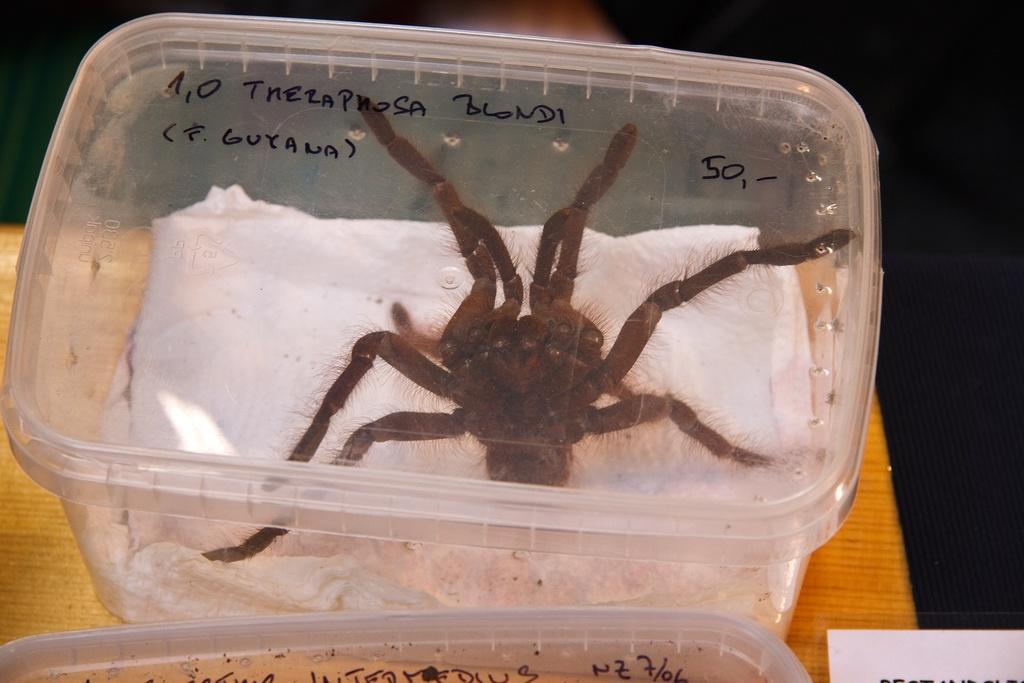Can you describe this image briefly? In this picture I can see e spider in the box and I can see another box at the bottom of the picture on the table and I can see text on the boxes 